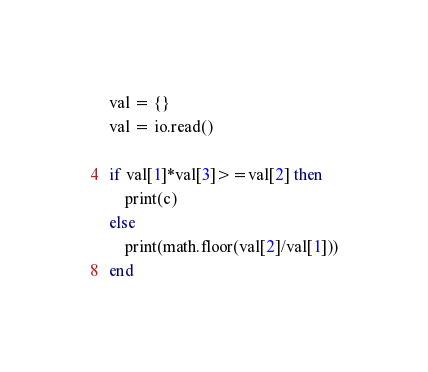Convert code to text. <code><loc_0><loc_0><loc_500><loc_500><_Lua_>val = {}
val = io.read()

if val[1]*val[3]>=val[2] then
	print(c)
else
	print(math.floor(val[2]/val[1]))
end
</code> 